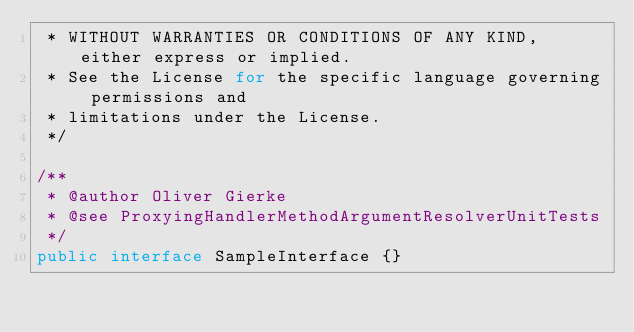Convert code to text. <code><loc_0><loc_0><loc_500><loc_500><_Java_> * WITHOUT WARRANTIES OR CONDITIONS OF ANY KIND, either express or implied.
 * See the License for the specific language governing permissions and
 * limitations under the License.
 */

/**
 * @author Oliver Gierke
 * @see ProxyingHandlerMethodArgumentResolverUnitTests
 */
public interface SampleInterface {}
</code> 